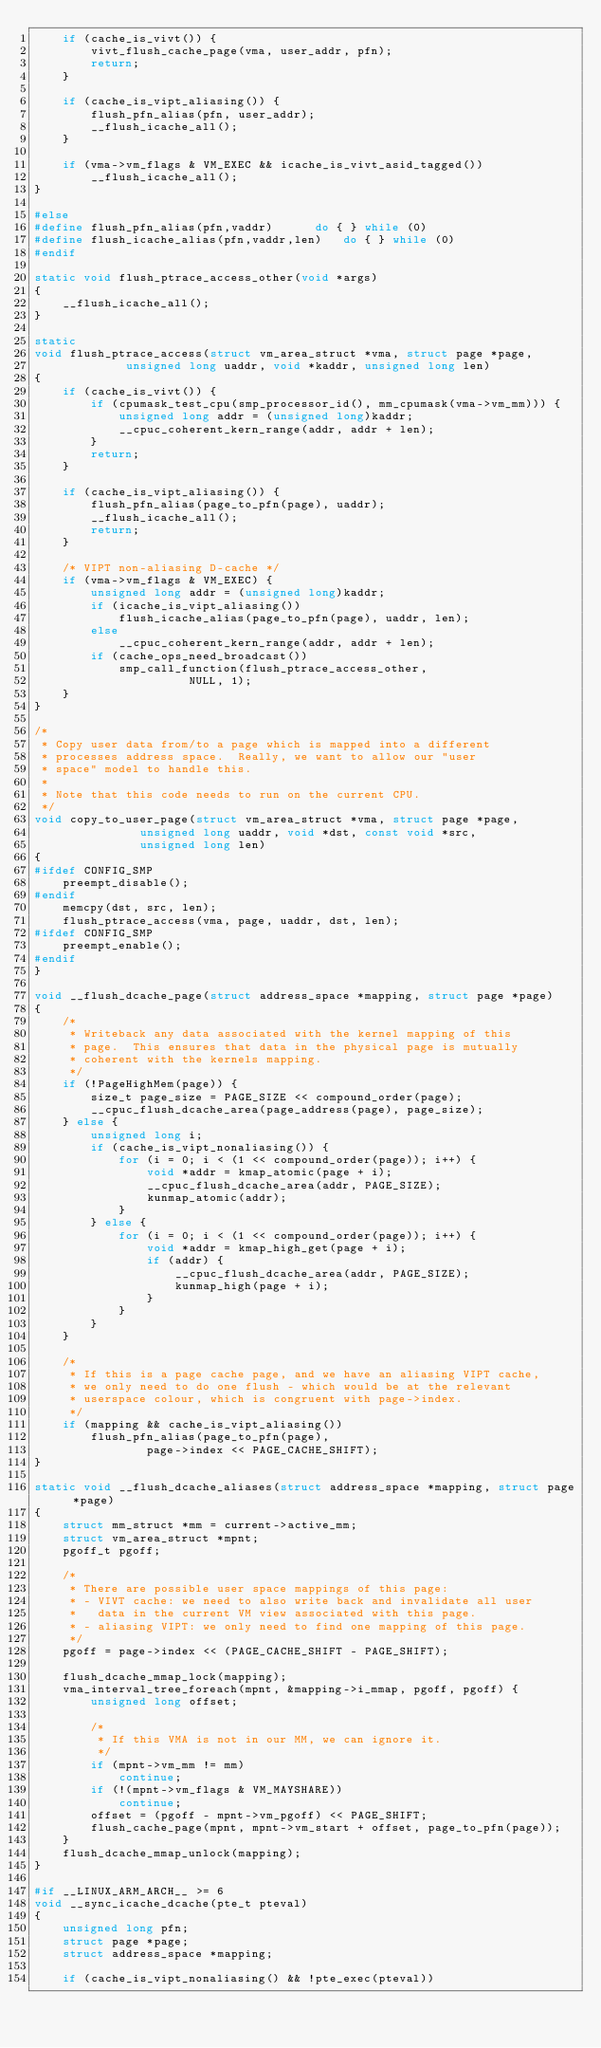Convert code to text. <code><loc_0><loc_0><loc_500><loc_500><_C_>	if (cache_is_vivt()) {
		vivt_flush_cache_page(vma, user_addr, pfn);
		return;
	}

	if (cache_is_vipt_aliasing()) {
		flush_pfn_alias(pfn, user_addr);
		__flush_icache_all();
	}

	if (vma->vm_flags & VM_EXEC && icache_is_vivt_asid_tagged())
		__flush_icache_all();
}

#else
#define flush_pfn_alias(pfn,vaddr)		do { } while (0)
#define flush_icache_alias(pfn,vaddr,len)	do { } while (0)
#endif

static void flush_ptrace_access_other(void *args)
{
	__flush_icache_all();
}

static
void flush_ptrace_access(struct vm_area_struct *vma, struct page *page,
			 unsigned long uaddr, void *kaddr, unsigned long len)
{
	if (cache_is_vivt()) {
		if (cpumask_test_cpu(smp_processor_id(), mm_cpumask(vma->vm_mm))) {
			unsigned long addr = (unsigned long)kaddr;
			__cpuc_coherent_kern_range(addr, addr + len);
		}
		return;
	}

	if (cache_is_vipt_aliasing()) {
		flush_pfn_alias(page_to_pfn(page), uaddr);
		__flush_icache_all();
		return;
	}

	/* VIPT non-aliasing D-cache */
	if (vma->vm_flags & VM_EXEC) {
		unsigned long addr = (unsigned long)kaddr;
		if (icache_is_vipt_aliasing())
			flush_icache_alias(page_to_pfn(page), uaddr, len);
		else
			__cpuc_coherent_kern_range(addr, addr + len);
		if (cache_ops_need_broadcast())
			smp_call_function(flush_ptrace_access_other,
					  NULL, 1);
	}
}

/*
 * Copy user data from/to a page which is mapped into a different
 * processes address space.  Really, we want to allow our "user
 * space" model to handle this.
 *
 * Note that this code needs to run on the current CPU.
 */
void copy_to_user_page(struct vm_area_struct *vma, struct page *page,
		       unsigned long uaddr, void *dst, const void *src,
		       unsigned long len)
{
#ifdef CONFIG_SMP
	preempt_disable();
#endif
	memcpy(dst, src, len);
	flush_ptrace_access(vma, page, uaddr, dst, len);
#ifdef CONFIG_SMP
	preempt_enable();
#endif
}

void __flush_dcache_page(struct address_space *mapping, struct page *page)
{
	/*
	 * Writeback any data associated with the kernel mapping of this
	 * page.  This ensures that data in the physical page is mutually
	 * coherent with the kernels mapping.
	 */
	if (!PageHighMem(page)) {
		size_t page_size = PAGE_SIZE << compound_order(page);
		__cpuc_flush_dcache_area(page_address(page), page_size);
	} else {
		unsigned long i;
		if (cache_is_vipt_nonaliasing()) {
			for (i = 0; i < (1 << compound_order(page)); i++) {
				void *addr = kmap_atomic(page + i);
				__cpuc_flush_dcache_area(addr, PAGE_SIZE);
				kunmap_atomic(addr);
			}
		} else {
			for (i = 0; i < (1 << compound_order(page)); i++) {
				void *addr = kmap_high_get(page + i);
				if (addr) {
					__cpuc_flush_dcache_area(addr, PAGE_SIZE);
					kunmap_high(page + i);
				}
			}
		}
	}

	/*
	 * If this is a page cache page, and we have an aliasing VIPT cache,
	 * we only need to do one flush - which would be at the relevant
	 * userspace colour, which is congruent with page->index.
	 */
	if (mapping && cache_is_vipt_aliasing())
		flush_pfn_alias(page_to_pfn(page),
				page->index << PAGE_CACHE_SHIFT);
}

static void __flush_dcache_aliases(struct address_space *mapping, struct page *page)
{
	struct mm_struct *mm = current->active_mm;
	struct vm_area_struct *mpnt;
	pgoff_t pgoff;

	/*
	 * There are possible user space mappings of this page:
	 * - VIVT cache: we need to also write back and invalidate all user
	 *   data in the current VM view associated with this page.
	 * - aliasing VIPT: we only need to find one mapping of this page.
	 */
	pgoff = page->index << (PAGE_CACHE_SHIFT - PAGE_SHIFT);

	flush_dcache_mmap_lock(mapping);
	vma_interval_tree_foreach(mpnt, &mapping->i_mmap, pgoff, pgoff) {
		unsigned long offset;

		/*
		 * If this VMA is not in our MM, we can ignore it.
		 */
		if (mpnt->vm_mm != mm)
			continue;
		if (!(mpnt->vm_flags & VM_MAYSHARE))
			continue;
		offset = (pgoff - mpnt->vm_pgoff) << PAGE_SHIFT;
		flush_cache_page(mpnt, mpnt->vm_start + offset, page_to_pfn(page));
	}
	flush_dcache_mmap_unlock(mapping);
}

#if __LINUX_ARM_ARCH__ >= 6
void __sync_icache_dcache(pte_t pteval)
{
	unsigned long pfn;
	struct page *page;
	struct address_space *mapping;

	if (cache_is_vipt_nonaliasing() && !pte_exec(pteval))</code> 